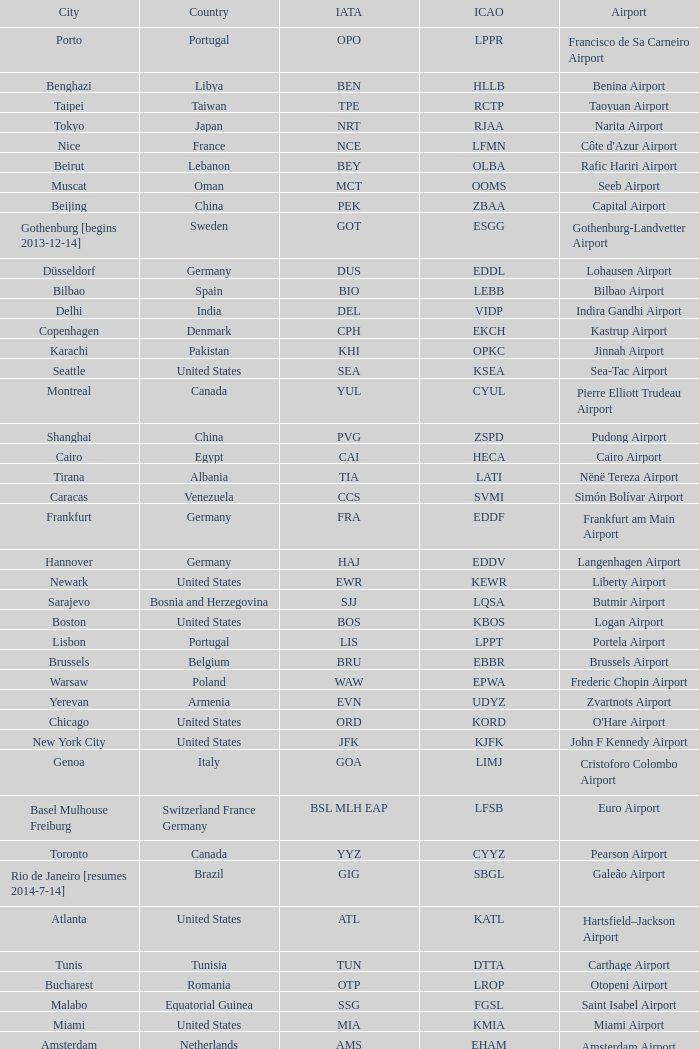What is the ICAO of Douala city? FKKD. 